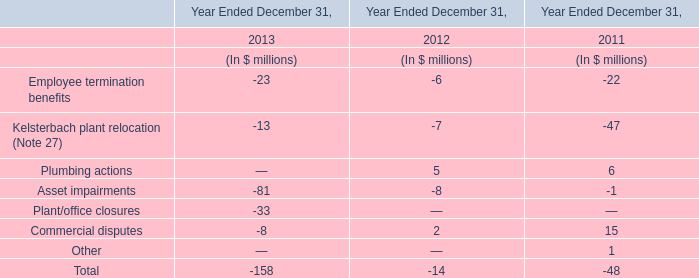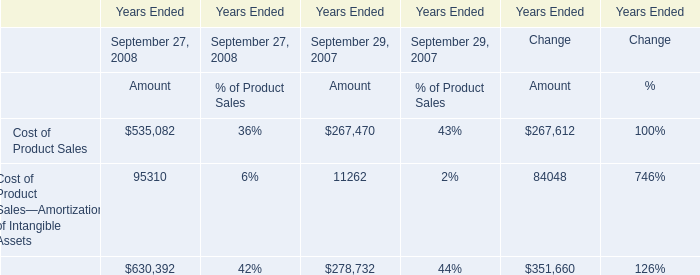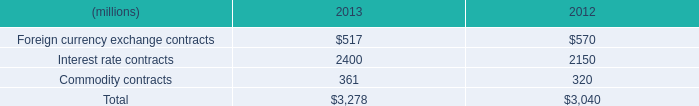What's the average of Cost of Product Sales of Years Ended Change Amount, and Interest rate contracts of 2013 ? 
Computations: ((267612.0 + 2400.0) / 2)
Answer: 135006.0. 